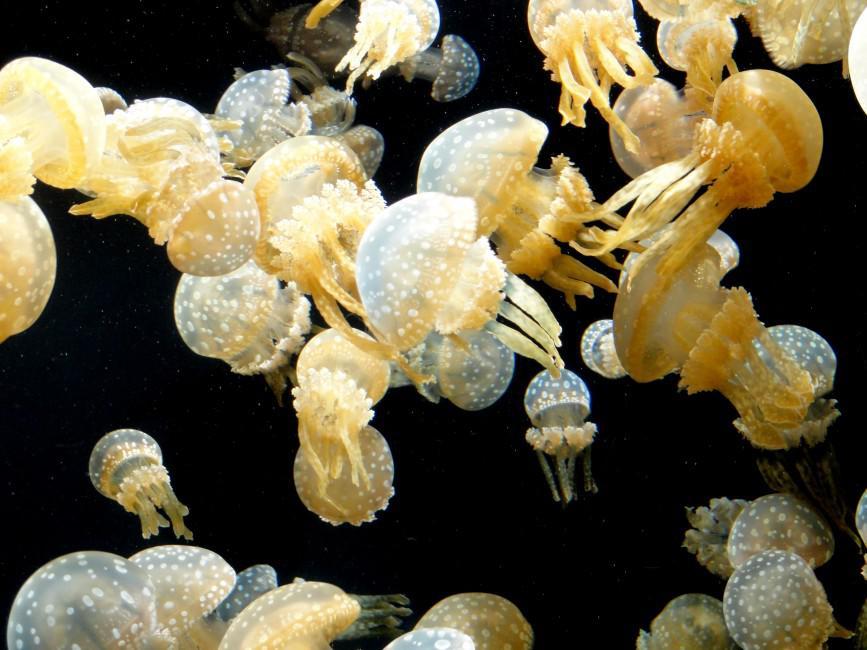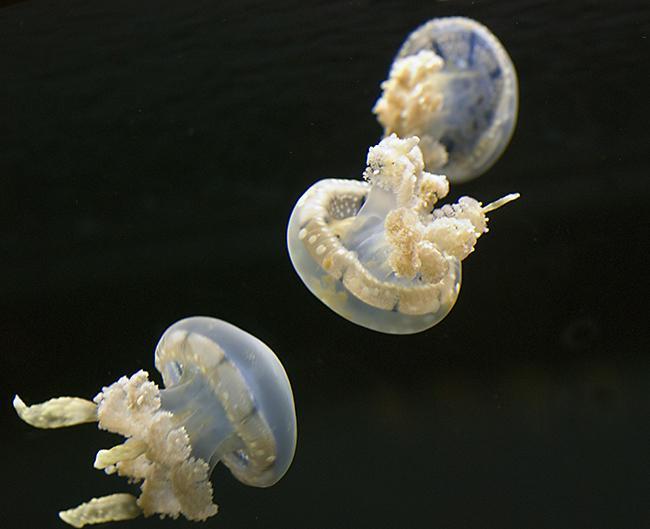The first image is the image on the left, the second image is the image on the right. Analyze the images presented: Is the assertion "The right image has fewer than four jellyfish." valid? Answer yes or no. Yes. The first image is the image on the left, the second image is the image on the right. For the images shown, is this caption "Right and left images each show the same neutral-colored type of jellyfish." true? Answer yes or no. Yes. 